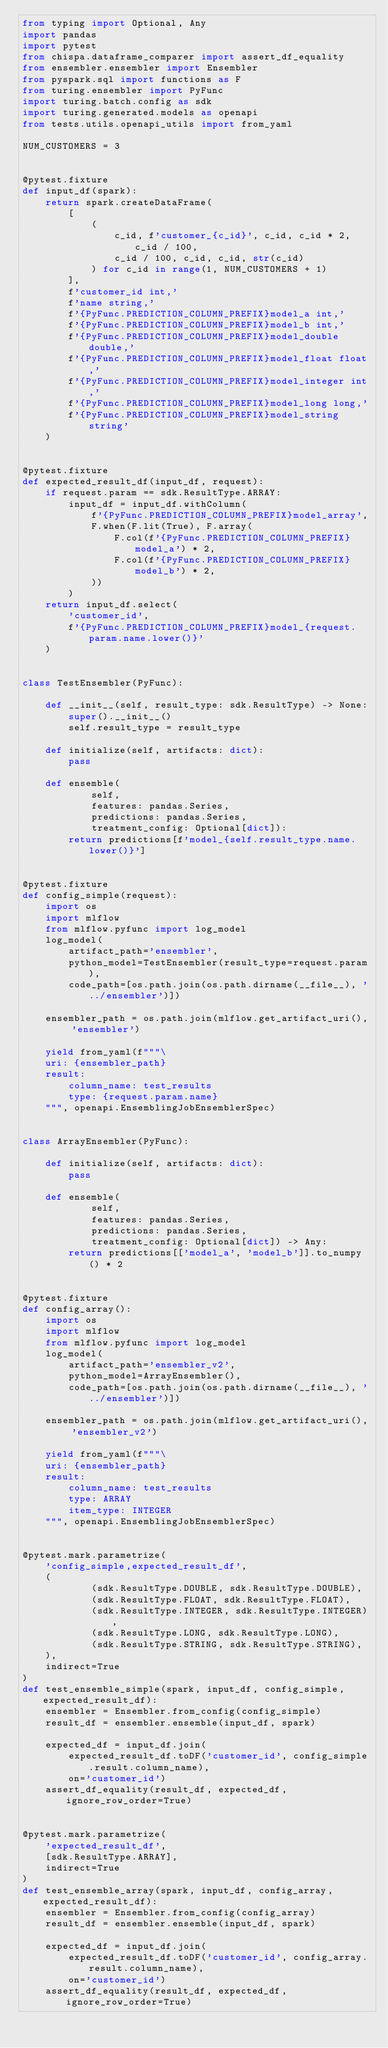Convert code to text. <code><loc_0><loc_0><loc_500><loc_500><_Python_>from typing import Optional, Any
import pandas
import pytest
from chispa.dataframe_comparer import assert_df_equality
from ensembler.ensembler import Ensembler
from pyspark.sql import functions as F
from turing.ensembler import PyFunc
import turing.batch.config as sdk
import turing.generated.models as openapi
from tests.utils.openapi_utils import from_yaml

NUM_CUSTOMERS = 3


@pytest.fixture
def input_df(spark):
    return spark.createDataFrame(
        [
            (
                c_id, f'customer_{c_id}', c_id, c_id * 2, c_id / 100,
                c_id / 100, c_id, c_id, str(c_id)
            ) for c_id in range(1, NUM_CUSTOMERS + 1)
        ],
        f'customer_id int,'
        f'name string,'
        f'{PyFunc.PREDICTION_COLUMN_PREFIX}model_a int,'
        f'{PyFunc.PREDICTION_COLUMN_PREFIX}model_b int,'
        f'{PyFunc.PREDICTION_COLUMN_PREFIX}model_double double,'
        f'{PyFunc.PREDICTION_COLUMN_PREFIX}model_float float,'
        f'{PyFunc.PREDICTION_COLUMN_PREFIX}model_integer int,'
        f'{PyFunc.PREDICTION_COLUMN_PREFIX}model_long long,'
        f'{PyFunc.PREDICTION_COLUMN_PREFIX}model_string string'
    )


@pytest.fixture
def expected_result_df(input_df, request):
    if request.param == sdk.ResultType.ARRAY:
        input_df = input_df.withColumn(
            f'{PyFunc.PREDICTION_COLUMN_PREFIX}model_array',
            F.when(F.lit(True), F.array(
                F.col(f'{PyFunc.PREDICTION_COLUMN_PREFIX}model_a') * 2,
                F.col(f'{PyFunc.PREDICTION_COLUMN_PREFIX}model_b') * 2,
            ))
        )
    return input_df.select(
        'customer_id',
        f'{PyFunc.PREDICTION_COLUMN_PREFIX}model_{request.param.name.lower()}'
    )


class TestEnsembler(PyFunc):

    def __init__(self, result_type: sdk.ResultType) -> None:
        super().__init__()
        self.result_type = result_type

    def initialize(self, artifacts: dict):
        pass

    def ensemble(
            self,
            features: pandas.Series,
            predictions: pandas.Series,
            treatment_config: Optional[dict]):
        return predictions[f'model_{self.result_type.name.lower()}']


@pytest.fixture
def config_simple(request):
    import os
    import mlflow
    from mlflow.pyfunc import log_model
    log_model(
        artifact_path='ensembler',
        python_model=TestEnsembler(result_type=request.param),
        code_path=[os.path.join(os.path.dirname(__file__), '../ensembler')])

    ensembler_path = os.path.join(mlflow.get_artifact_uri(), 'ensembler')

    yield from_yaml(f"""\
    uri: {ensembler_path}
    result:
        column_name: test_results
        type: {request.param.name}
    """, openapi.EnsemblingJobEnsemblerSpec)


class ArrayEnsembler(PyFunc):

    def initialize(self, artifacts: dict):
        pass

    def ensemble(
            self,
            features: pandas.Series,
            predictions: pandas.Series,
            treatment_config: Optional[dict]) -> Any:
        return predictions[['model_a', 'model_b']].to_numpy() * 2


@pytest.fixture
def config_array():
    import os
    import mlflow
    from mlflow.pyfunc import log_model
    log_model(
        artifact_path='ensembler_v2',
        python_model=ArrayEnsembler(),
        code_path=[os.path.join(os.path.dirname(__file__), '../ensembler')])

    ensembler_path = os.path.join(mlflow.get_artifact_uri(), 'ensembler_v2')

    yield from_yaml(f"""\
    uri: {ensembler_path}
    result:
        column_name: test_results
        type: ARRAY
        item_type: INTEGER
    """, openapi.EnsemblingJobEnsemblerSpec)


@pytest.mark.parametrize(
    'config_simple,expected_result_df',
    (
            (sdk.ResultType.DOUBLE, sdk.ResultType.DOUBLE),
            (sdk.ResultType.FLOAT, sdk.ResultType.FLOAT),
            (sdk.ResultType.INTEGER, sdk.ResultType.INTEGER),
            (sdk.ResultType.LONG, sdk.ResultType.LONG),
            (sdk.ResultType.STRING, sdk.ResultType.STRING),
    ),
    indirect=True
)
def test_ensemble_simple(spark, input_df, config_simple, expected_result_df):
    ensembler = Ensembler.from_config(config_simple)
    result_df = ensembler.ensemble(input_df, spark)

    expected_df = input_df.join(
        expected_result_df.toDF('customer_id', config_simple.result.column_name),
        on='customer_id')
    assert_df_equality(result_df, expected_df, ignore_row_order=True)


@pytest.mark.parametrize(
    'expected_result_df',
    [sdk.ResultType.ARRAY],
    indirect=True
)
def test_ensemble_array(spark, input_df, config_array, expected_result_df):
    ensembler = Ensembler.from_config(config_array)
    result_df = ensembler.ensemble(input_df, spark)

    expected_df = input_df.join(
        expected_result_df.toDF('customer_id', config_array.result.column_name),
        on='customer_id')
    assert_df_equality(result_df, expected_df, ignore_row_order=True)
</code> 